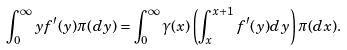Convert formula to latex. <formula><loc_0><loc_0><loc_500><loc_500>\int _ { 0 } ^ { \infty } y f ^ { \prime } ( y ) \pi ( d y ) = \int _ { 0 } ^ { \infty } \gamma ( x ) \left ( \int _ { x } ^ { x + 1 } f ^ { \prime } ( y ) d y \right ) \pi ( d x ) .</formula> 